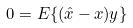<formula> <loc_0><loc_0><loc_500><loc_500>0 = E \{ ( \hat { x } - x ) y \}</formula> 